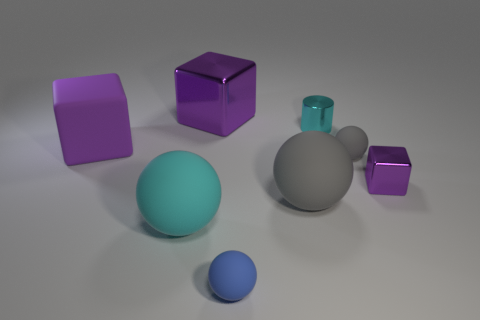There is another small cube that is the same color as the matte cube; what material is it?
Provide a short and direct response. Metal. There is a metal object that is to the left of the cylinder; is its size the same as the metallic block that is in front of the big purple shiny thing?
Make the answer very short. No. Are there any balls left of the small gray ball?
Your response must be concise. Yes. There is a cube right of the tiny ball behind the big gray thing; what color is it?
Provide a short and direct response. Purple. Is the number of purple matte cubes less than the number of large cubes?
Provide a short and direct response. Yes. What number of blue rubber objects have the same shape as the large gray rubber object?
Give a very brief answer. 1. The ball that is the same size as the cyan rubber object is what color?
Your answer should be very brief. Gray. Is the number of large gray things that are left of the blue ball the same as the number of metal cylinders that are to the left of the large rubber block?
Offer a terse response. Yes. Are there any other shiny cylinders that have the same size as the cyan cylinder?
Provide a succinct answer. No. What is the size of the blue rubber ball?
Ensure brevity in your answer.  Small. 